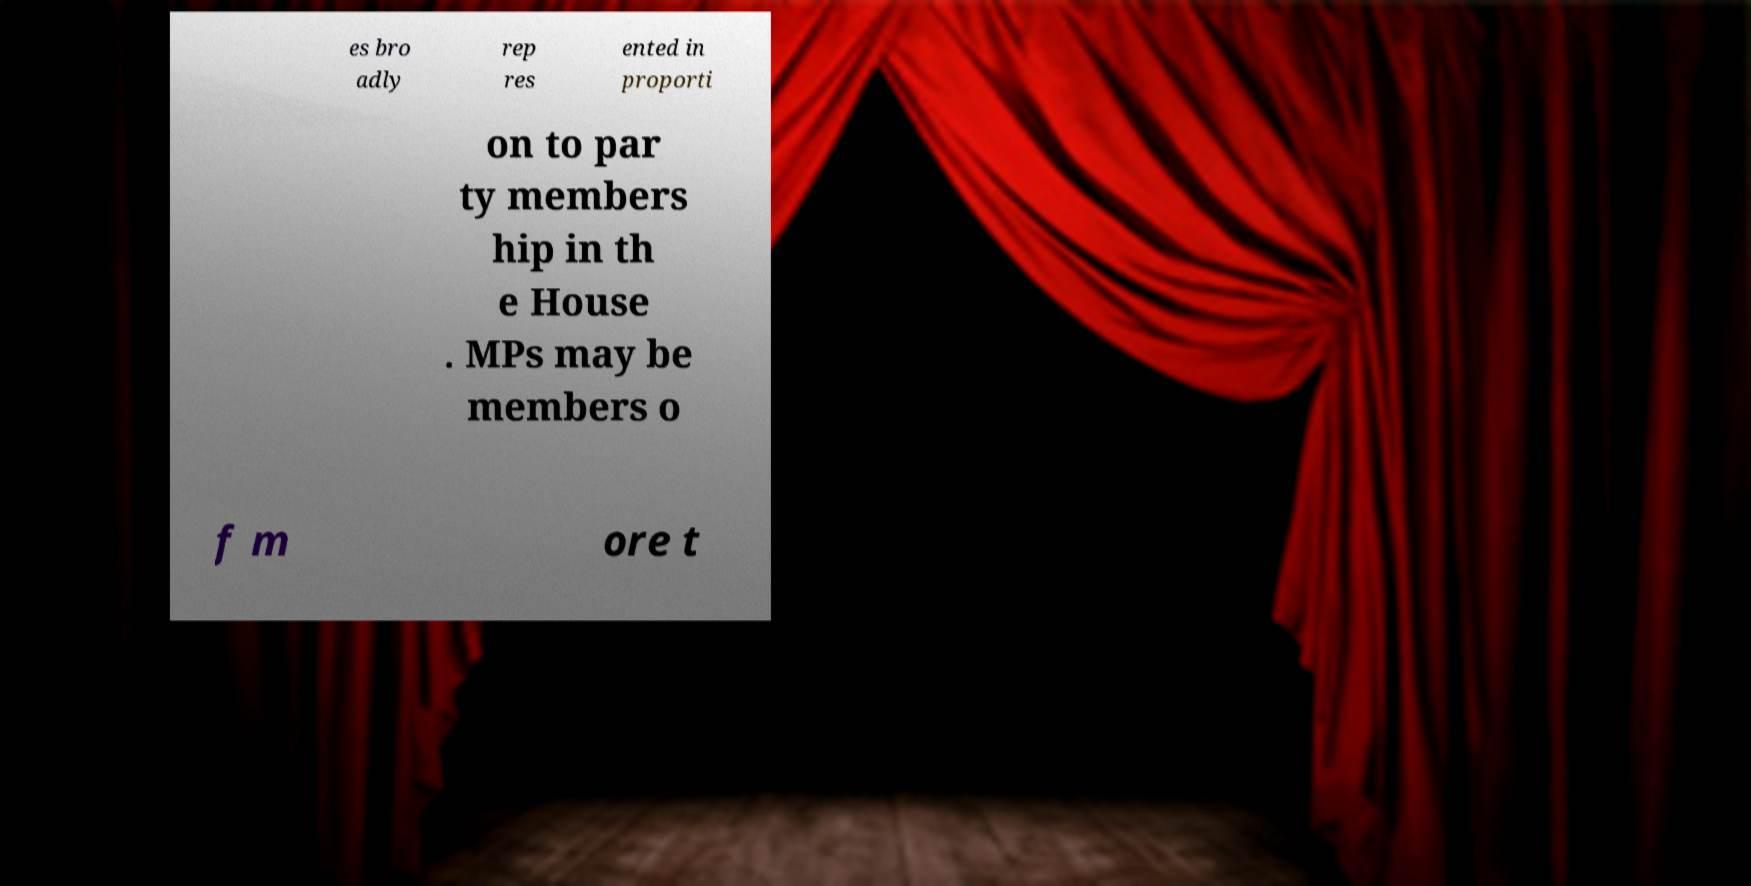For documentation purposes, I need the text within this image transcribed. Could you provide that? es bro adly rep res ented in proporti on to par ty members hip in th e House . MPs may be members o f m ore t 